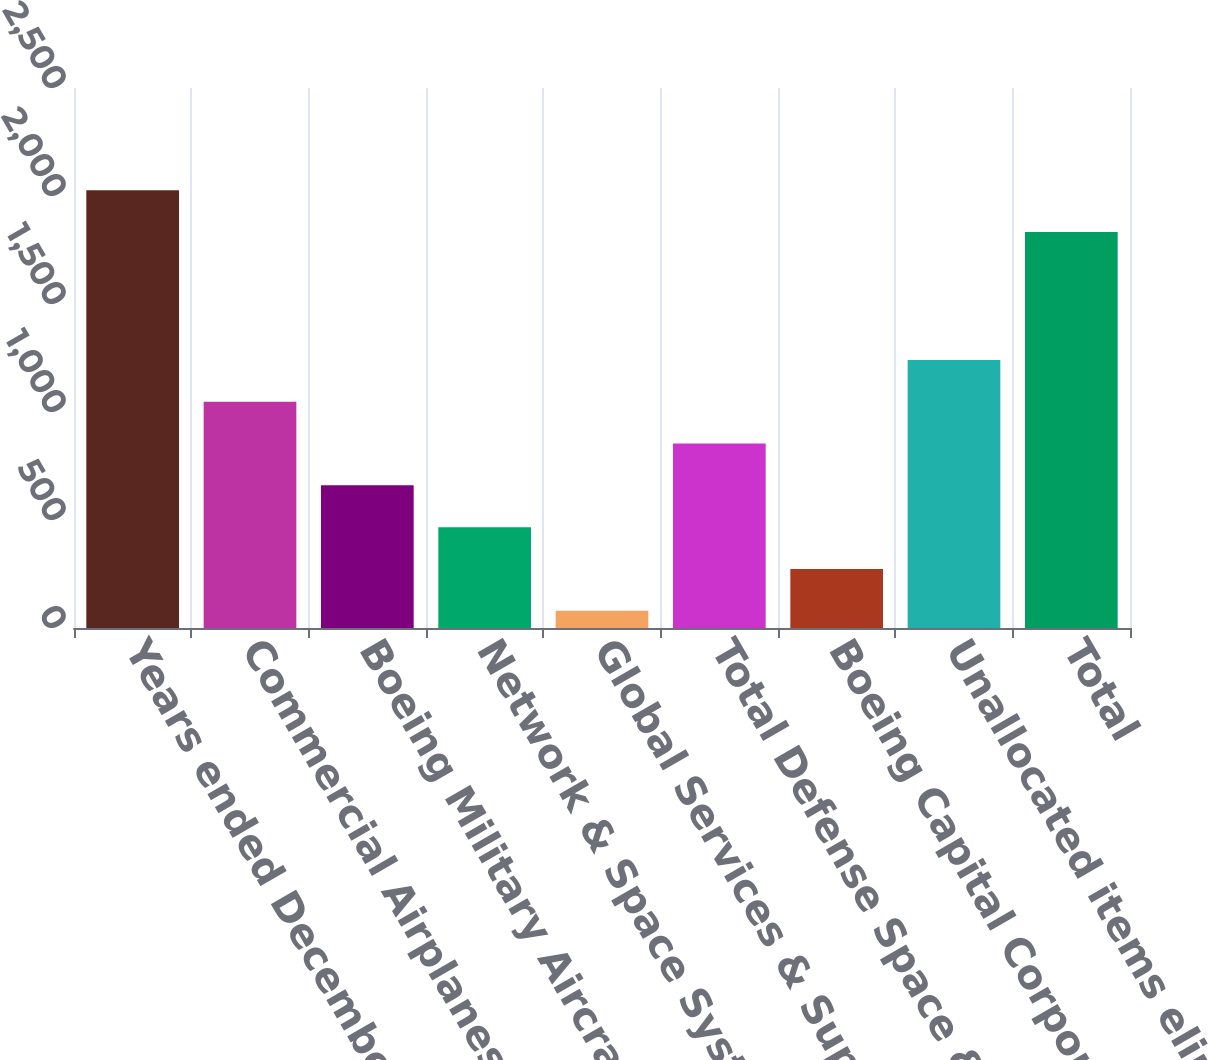Convert chart to OTSL. <chart><loc_0><loc_0><loc_500><loc_500><bar_chart><fcel>Years ended December 31<fcel>Commercial Airplanes<fcel>Boeing Military Aircraft<fcel>Network & Space Systems<fcel>Global Services & Support<fcel>Total Defense Space & Security<fcel>Boeing Capital Corporation<fcel>Unallocated items eliminations<fcel>Total<nl><fcel>2026.5<fcel>1047.5<fcel>660.5<fcel>467<fcel>80<fcel>854<fcel>273.5<fcel>1241<fcel>1833<nl></chart> 